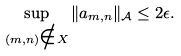Convert formula to latex. <formula><loc_0><loc_0><loc_500><loc_500>\sup _ { ( m , n ) \notin X } \| a _ { m , n } \| _ { \mathcal { A } } \leq 2 \epsilon .</formula> 